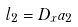<formula> <loc_0><loc_0><loc_500><loc_500>l _ { 2 } = D _ { x } a _ { 2 }</formula> 